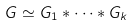<formula> <loc_0><loc_0><loc_500><loc_500>G \simeq G _ { 1 } \ast \cdots \ast G _ { k }</formula> 